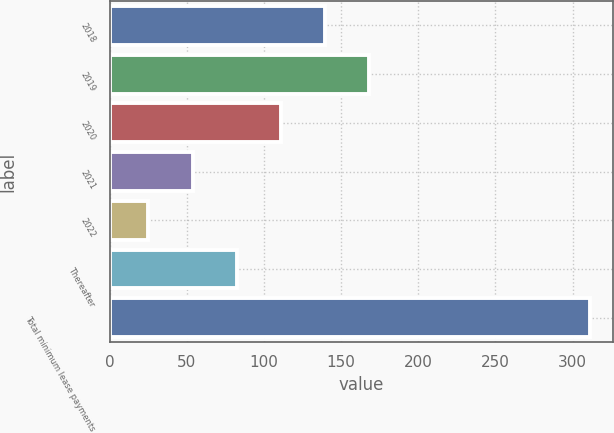Convert chart. <chart><loc_0><loc_0><loc_500><loc_500><bar_chart><fcel>2018<fcel>2019<fcel>2020<fcel>2021<fcel>2022<fcel>Thereafter<fcel>Total minimum lease payments<nl><fcel>139.4<fcel>168<fcel>110.8<fcel>53.6<fcel>25<fcel>82.2<fcel>311<nl></chart> 